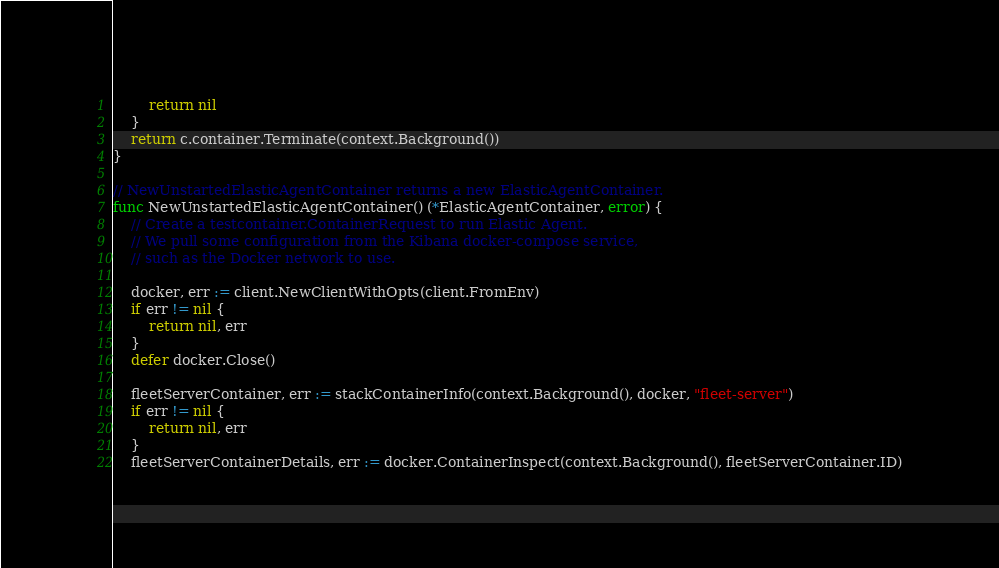<code> <loc_0><loc_0><loc_500><loc_500><_Go_>		return nil
	}
	return c.container.Terminate(context.Background())
}

// NewUnstartedElasticAgentContainer returns a new ElasticAgentContainer.
func NewUnstartedElasticAgentContainer() (*ElasticAgentContainer, error) {
	// Create a testcontainer.ContainerRequest to run Elastic Agent.
	// We pull some configuration from the Kibana docker-compose service,
	// such as the Docker network to use.

	docker, err := client.NewClientWithOpts(client.FromEnv)
	if err != nil {
		return nil, err
	}
	defer docker.Close()

	fleetServerContainer, err := stackContainerInfo(context.Background(), docker, "fleet-server")
	if err != nil {
		return nil, err
	}
	fleetServerContainerDetails, err := docker.ContainerInspect(context.Background(), fleetServerContainer.ID)</code> 